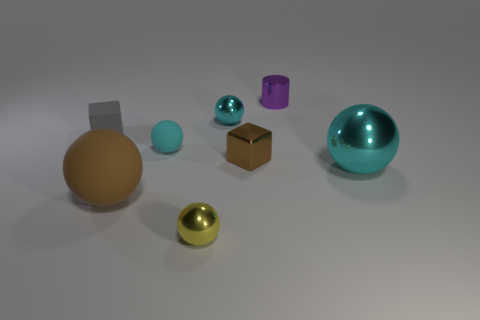Subtract all yellow cylinders. How many cyan spheres are left? 3 Subtract all brown balls. How many balls are left? 4 Subtract all brown balls. How many balls are left? 4 Subtract all gray balls. Subtract all gray blocks. How many balls are left? 5 Add 1 balls. How many objects exist? 9 Subtract all cylinders. How many objects are left? 7 Add 3 small brown objects. How many small brown objects exist? 4 Subtract 1 purple cylinders. How many objects are left? 7 Subtract all big purple matte balls. Subtract all tiny metallic cubes. How many objects are left? 7 Add 7 tiny brown metal blocks. How many tiny brown metal blocks are left? 8 